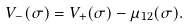<formula> <loc_0><loc_0><loc_500><loc_500>V _ { - } ( \sigma ) = V _ { + } ( \sigma ) - \mu _ { 1 2 } ( \sigma ) .</formula> 